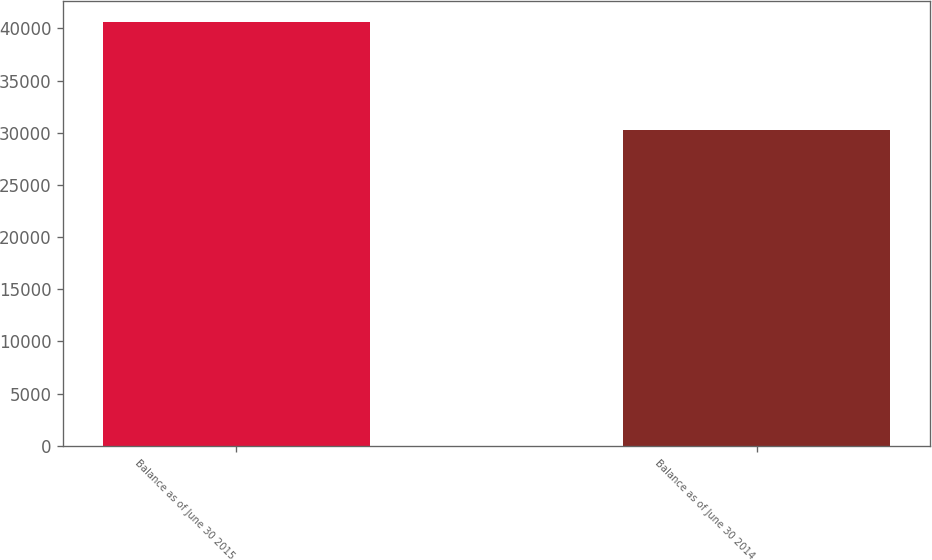Convert chart to OTSL. <chart><loc_0><loc_0><loc_500><loc_500><bar_chart><fcel>Balance as of June 30 2015<fcel>Balance as of June 30 2014<nl><fcel>40573<fcel>30271<nl></chart> 